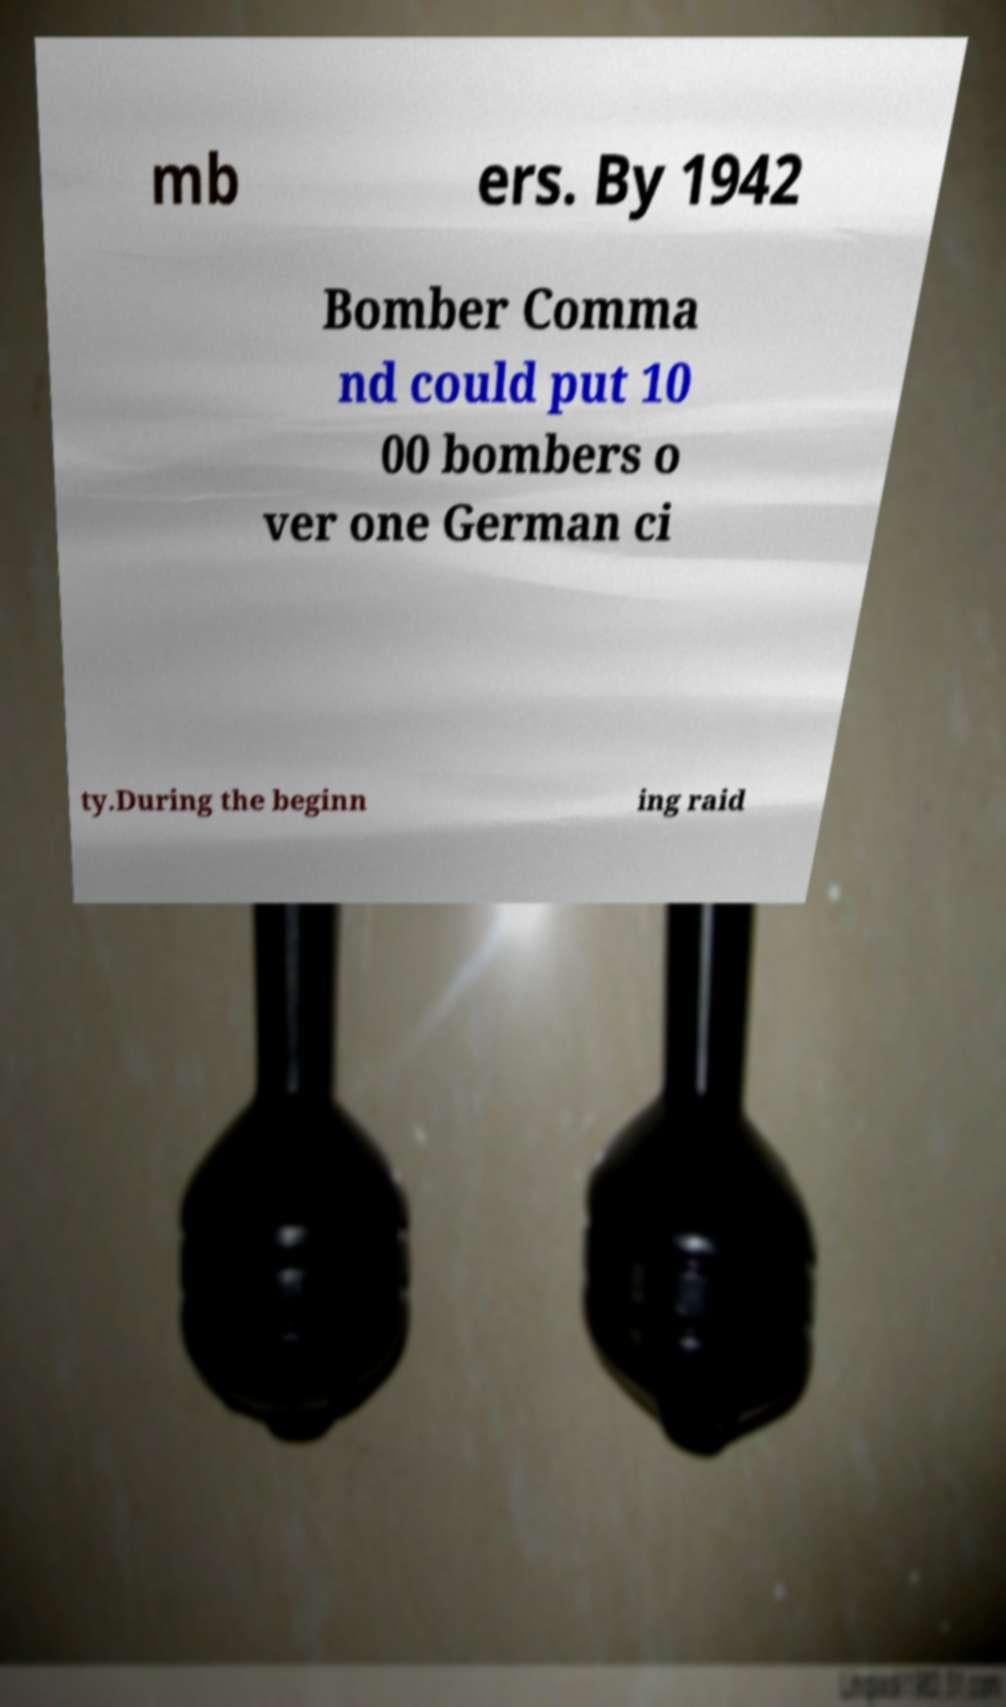Can you read and provide the text displayed in the image?This photo seems to have some interesting text. Can you extract and type it out for me? mb ers. By 1942 Bomber Comma nd could put 10 00 bombers o ver one German ci ty.During the beginn ing raid 